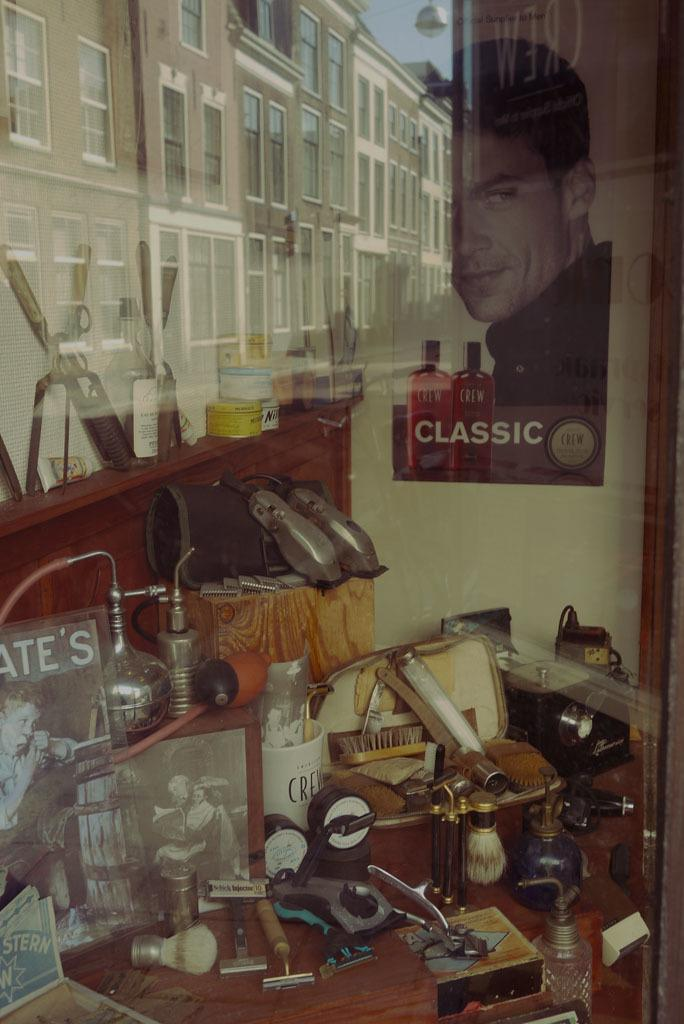<image>
Create a compact narrative representing the image presented. Cluttered bathroom vanity table and wall showing beauty supplies with a poster of a man with 'classic,' written in white text on wall. 